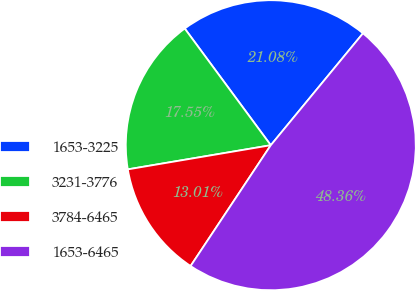<chart> <loc_0><loc_0><loc_500><loc_500><pie_chart><fcel>1653-3225<fcel>3231-3776<fcel>3784-6465<fcel>1653-6465<nl><fcel>21.08%<fcel>17.55%<fcel>13.01%<fcel>48.36%<nl></chart> 